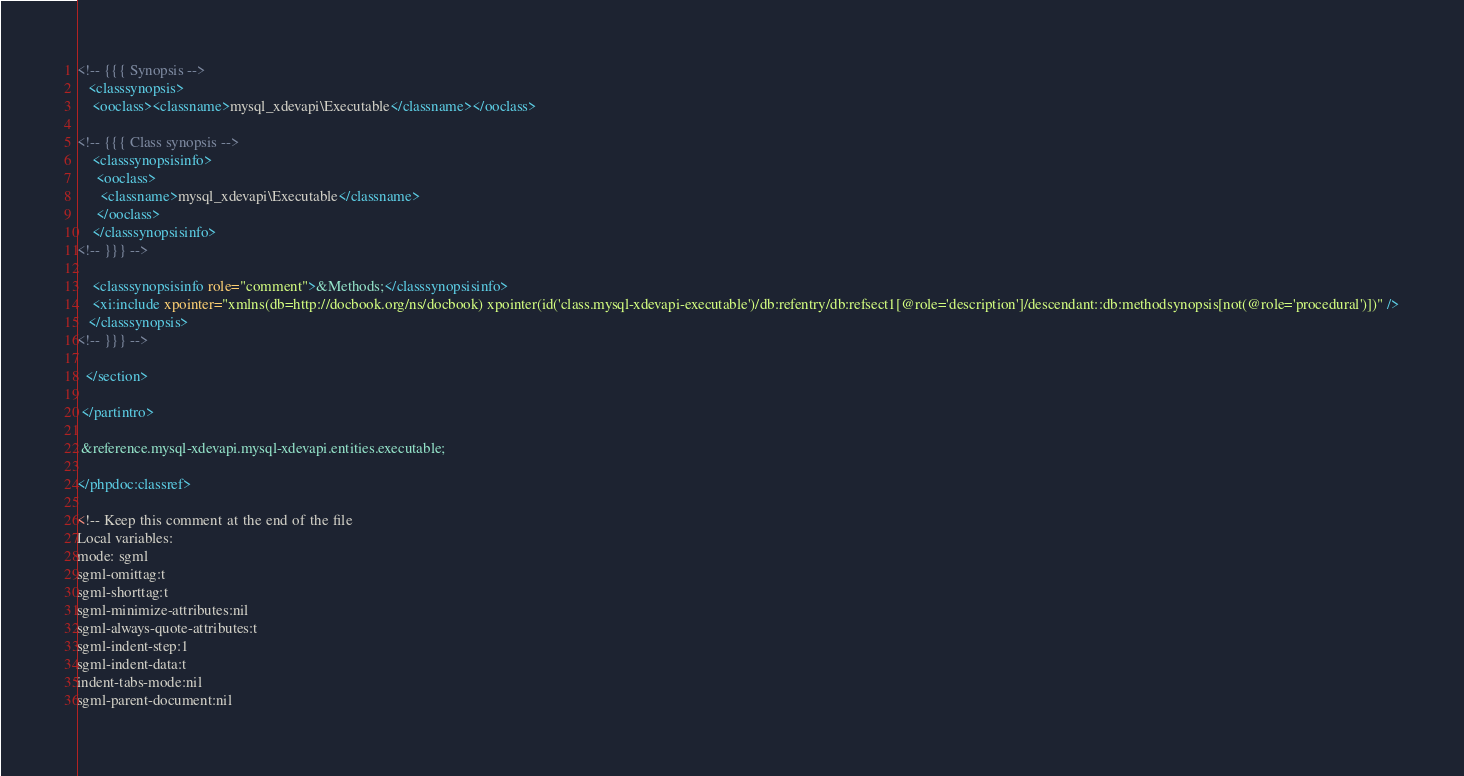<code> <loc_0><loc_0><loc_500><loc_500><_XML_>
<!-- {{{ Synopsis -->
   <classsynopsis>
    <ooclass><classname>mysql_xdevapi\Executable</classname></ooclass>

<!-- {{{ Class synopsis -->
    <classsynopsisinfo>
     <ooclass>
      <classname>mysql_xdevapi\Executable</classname>
     </ooclass>
    </classsynopsisinfo>
<!-- }}} -->
    
    <classsynopsisinfo role="comment">&Methods;</classsynopsisinfo>
    <xi:include xpointer="xmlns(db=http://docbook.org/ns/docbook) xpointer(id('class.mysql-xdevapi-executable')/db:refentry/db:refsect1[@role='description']/descendant::db:methodsynopsis[not(@role='procedural')])" />
   </classsynopsis>
<!-- }}} -->

  </section>

 </partintro>

 &reference.mysql-xdevapi.mysql-xdevapi.entities.executable;

</phpdoc:classref>

<!-- Keep this comment at the end of the file
Local variables:
mode: sgml
sgml-omittag:t
sgml-shorttag:t
sgml-minimize-attributes:nil
sgml-always-quote-attributes:t
sgml-indent-step:1
sgml-indent-data:t
indent-tabs-mode:nil
sgml-parent-document:nil</code> 